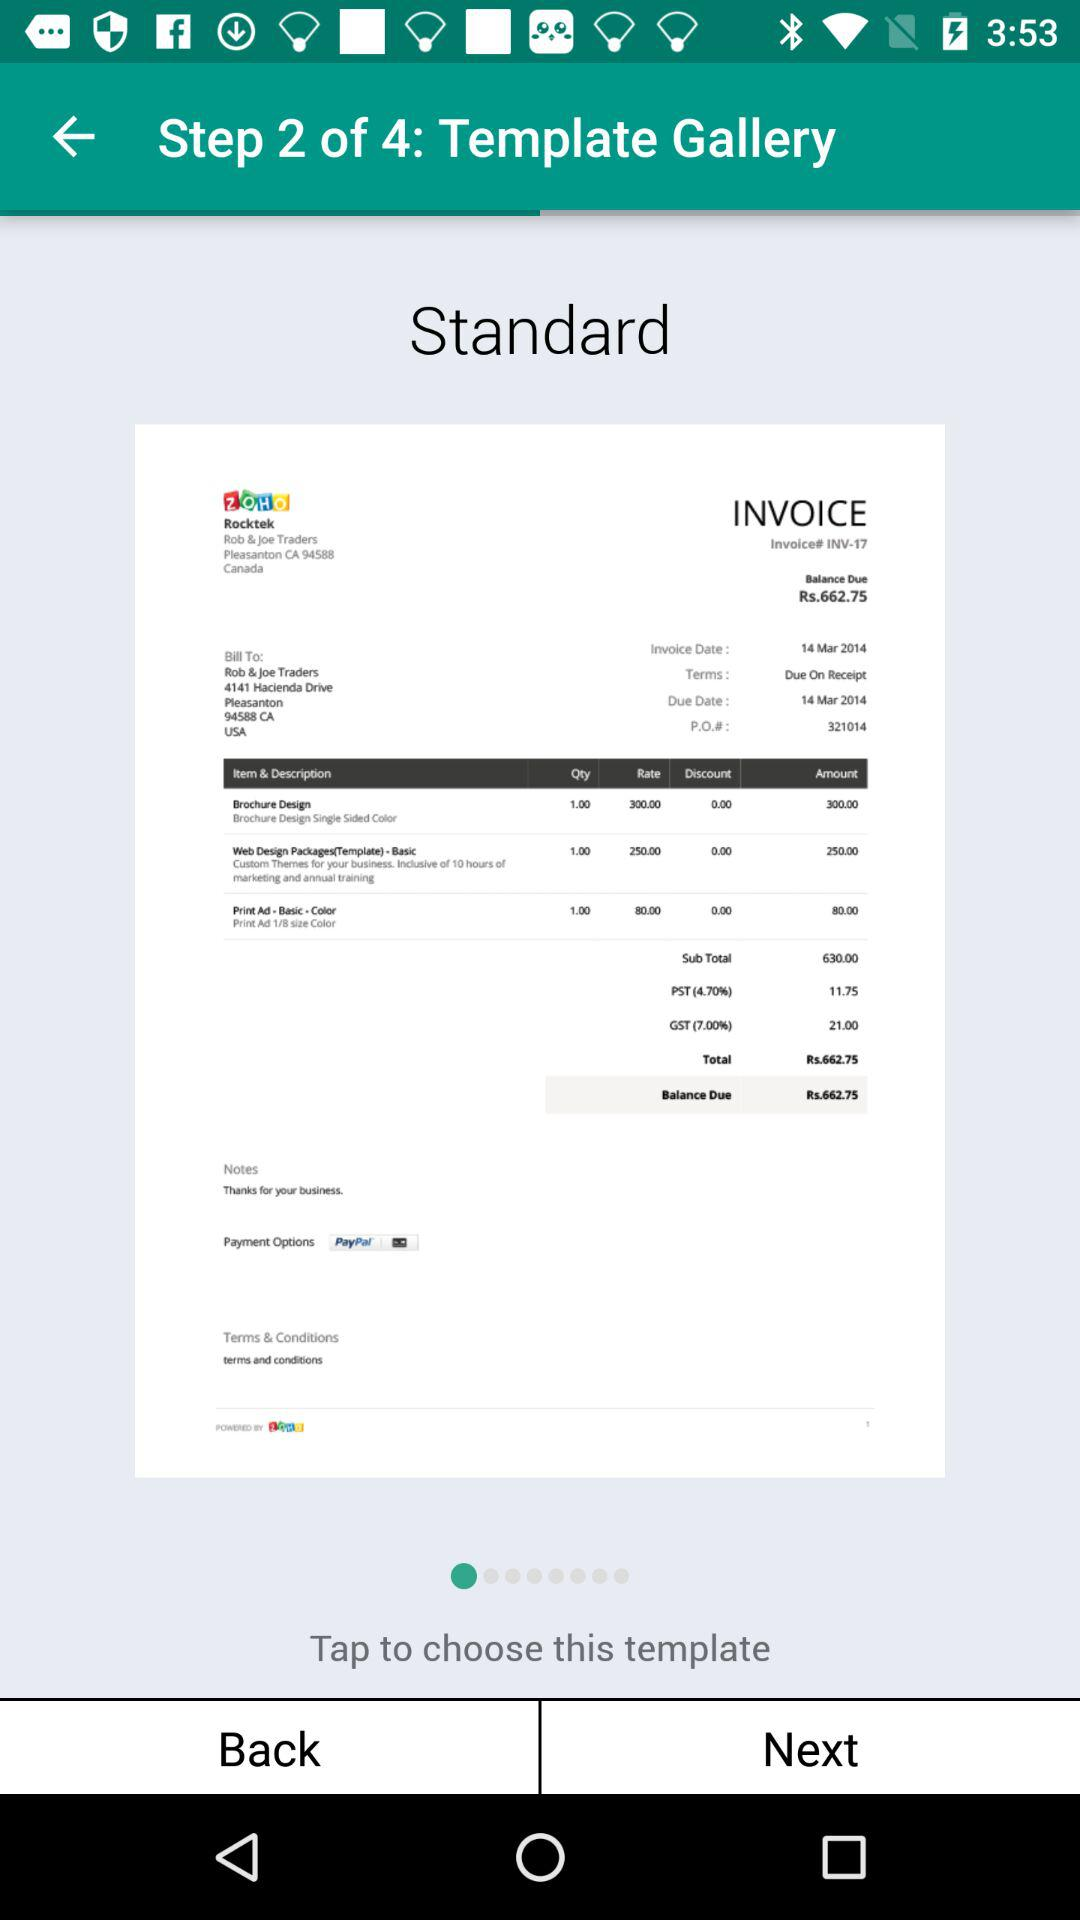At which step am I? You are at step 2. 